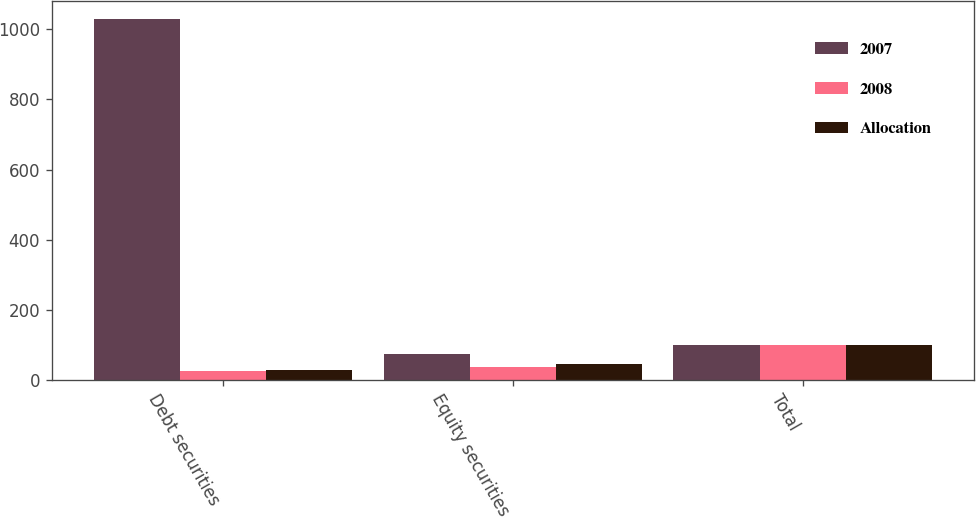Convert chart. <chart><loc_0><loc_0><loc_500><loc_500><stacked_bar_chart><ecel><fcel>Debt securities<fcel>Equity securities<fcel>Total<nl><fcel>2007<fcel>1030<fcel>72.5<fcel>100<nl><fcel>2008<fcel>25<fcel>36<fcel>100<nl><fcel>Allocation<fcel>28<fcel>45<fcel>100<nl></chart> 